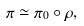Convert formula to latex. <formula><loc_0><loc_0><loc_500><loc_500>\pi \simeq \pi _ { 0 } \circ \rho ,</formula> 